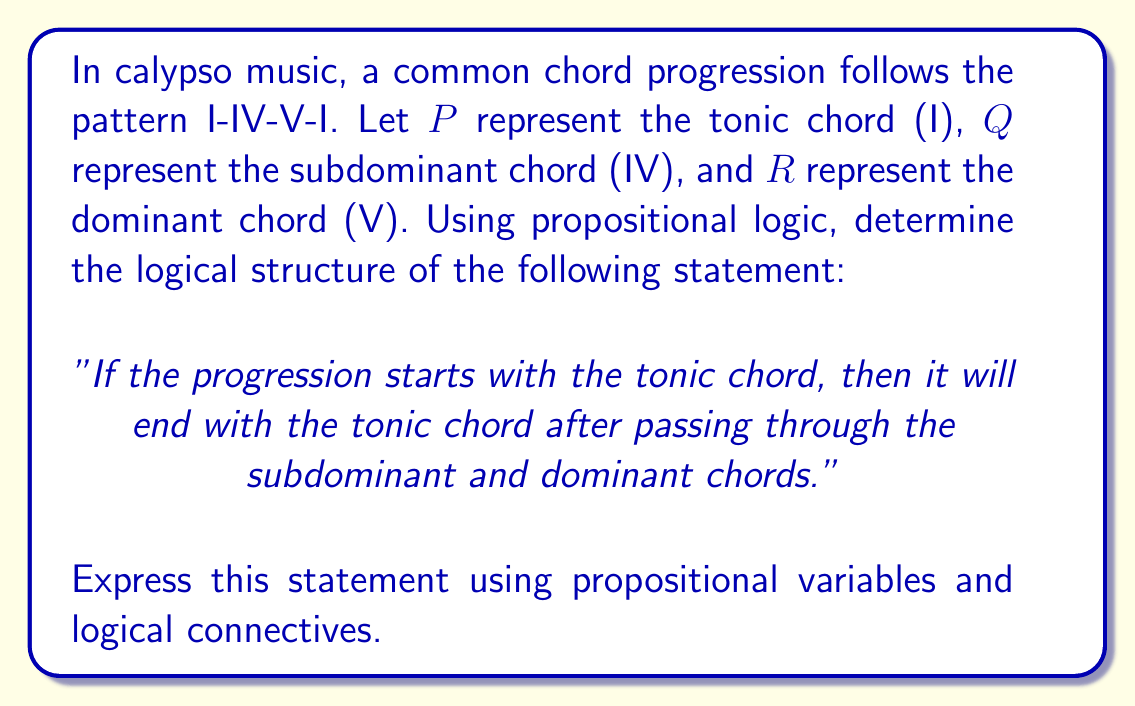Give your solution to this math problem. To solve this problem, we need to break down the statement into its logical components and use propositional logic to represent the chord progression. Let's approach this step-by-step:

1. Define our propositional variables:
   P: The progression includes the tonic chord (I)
   Q: The progression includes the subdominant chord (IV)
   R: The progression includes the dominant chord (V)

2. Analyze the statement:
   "If the progression starts with the tonic chord, then it will end with the tonic chord after passing through the subdominant and dominant chords."

3. Break down the logical structure:
   - The statement is an implication (if-then statement)
   - The antecedent (if part) is "the progression starts with the tonic chord"
   - The consequent (then part) is "it will end with the tonic chord after passing through the subdominant and dominant chords"

4. Represent the antecedent:
   - Starting with the tonic chord can be represented simply as P

5. Represent the consequent:
   - Ending with the tonic chord: P
   - Passing through subdominant and dominant chords: Q ∧ R
   - The order matters, so we need to represent this as a sequence: (Q ∧ R) ∧ P

6. Combine the antecedent and consequent using the implication operator (→):
   P → ((Q ∧ R) ∧ P)

This logical expression represents the given statement in propositional logic, capturing the structure of the I-IV-V-I chord progression in calypso music.
Answer: P → ((Q ∧ R) ∧ P) 